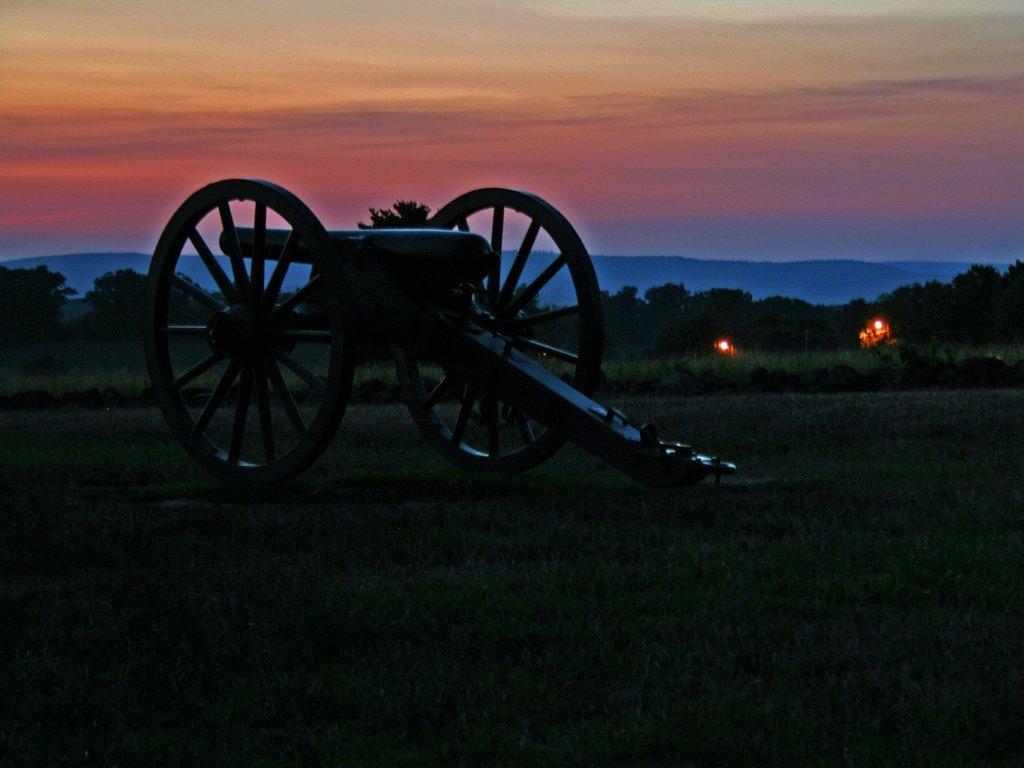Please provide a concise description of this image. there is a cannon in the center of the image on the grassland and there are lights and trees in the background area, there is sky at the top side of the image. 